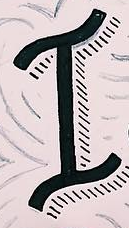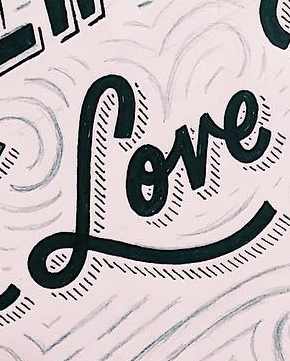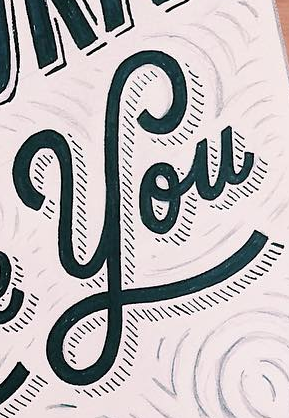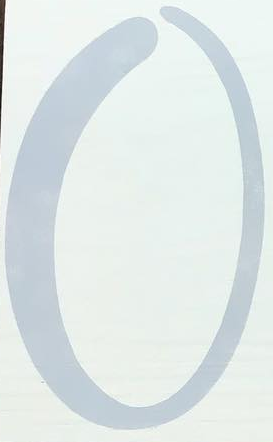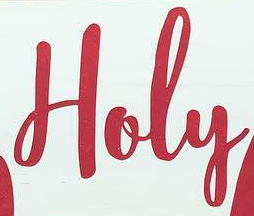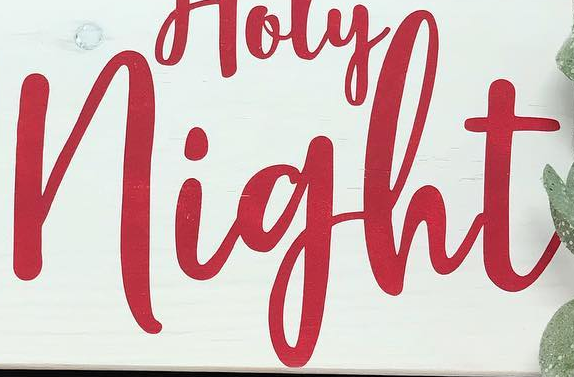What text appears in these images from left to right, separated by a semicolon? I; Love; You; O; Holy; night 